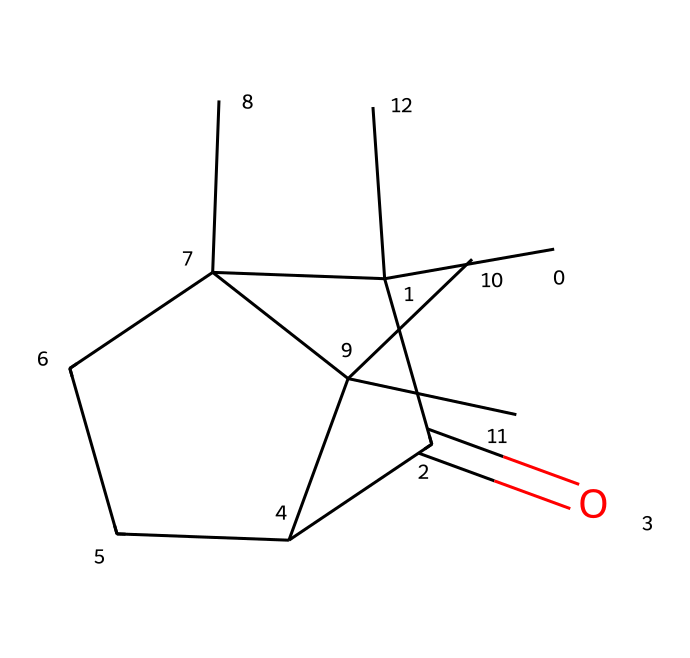How many carbon atoms are present in camphor? By analyzing the provided SMILES representation, we count the number of 'C' characters, which represent carbon atoms. In the structure, there are ten 'C' characters indicating that there are ten carbon atoms in camphor.
Answer: ten What is the primary functional group present in camphor? In the SMILES, the notation "C(=O)" signifies a carbonyl group, indicating that camphor contains a ketone functional group, which is the defining characteristic of the compound.
Answer: ketone How many cyclic structures does camphor contain? By examining the structure represented in the SMILES, the two cyclical segments indicated by the 'C' atoms connected in a ring-like manner show that camphor features two cyclic structures.
Answer: two What is the molecular formula for camphor? Analyzing the counts of each atom from the SMILES: 10 carbon (C), 16 hydrogen (H), and 1 oxygen (O) indicates that the molecular formula for camphor is C10H16O.
Answer: C10H16O Is camphor a saturated or unsaturated cyclic compound? Looking at the number of hydrogen atoms in relation to the number of carbon atoms, we note that camphor has all single bonds except for one carbonyl (C=O) bond, indicating that it is saturated.
Answer: saturated What type of cycloalkane structure does camphor represent? The structure presented has multiple rings showing fused cycles, which suggests that camphor is representative of a bicyclic structure in the cycloalkane category.
Answer: bicyclic 